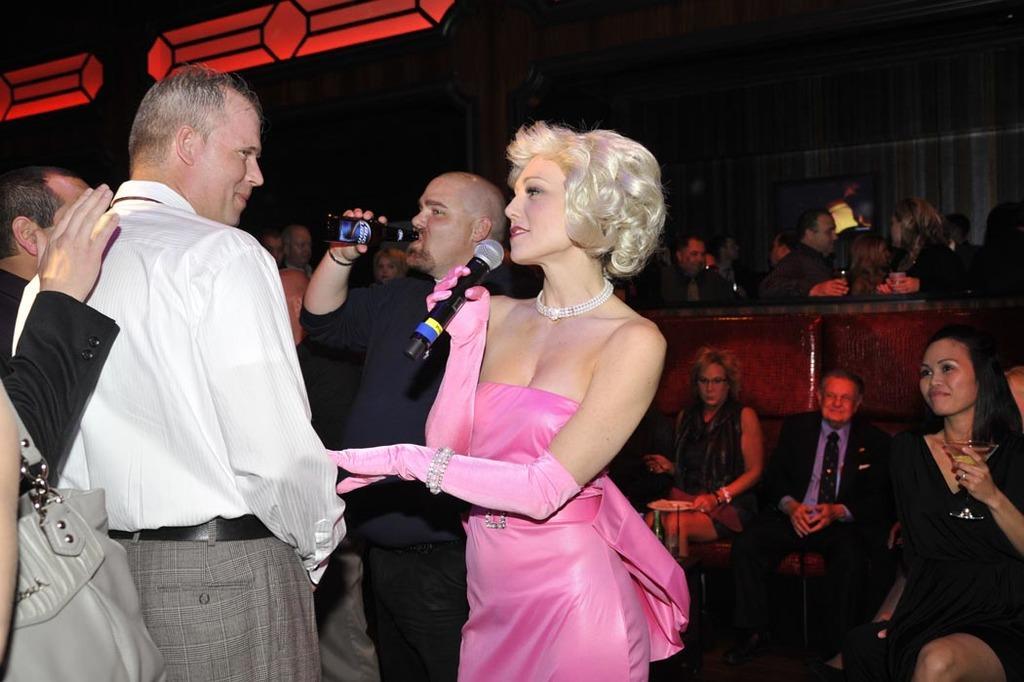Describe this image in one or two sentences. In this image there are people sitting and some of them are standing. The lady standing in the center is holding a mic, next to her there is a man holding a bottle. At the top there are lights. 